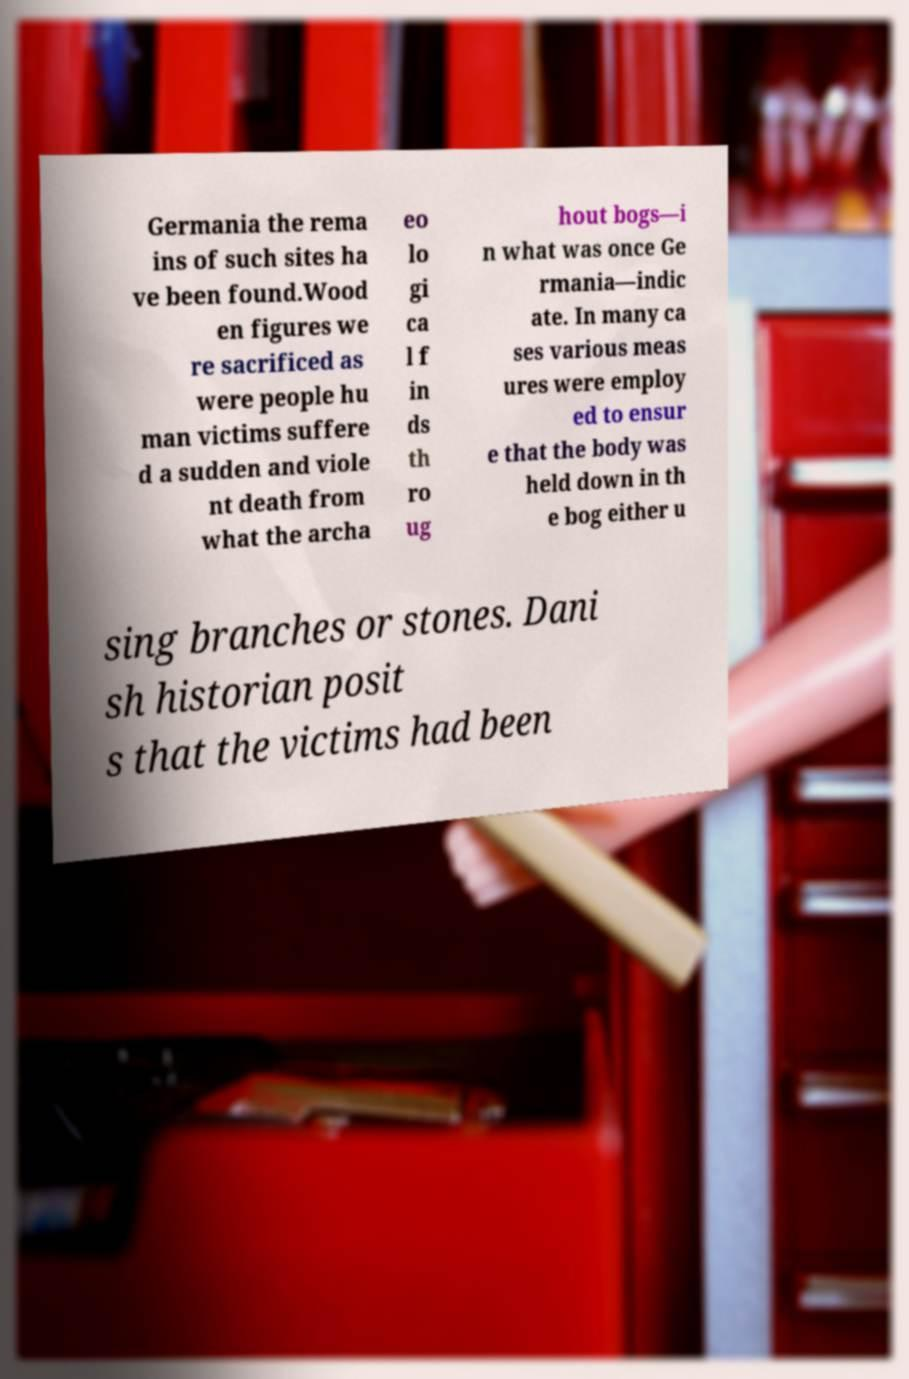I need the written content from this picture converted into text. Can you do that? Germania the rema ins of such sites ha ve been found.Wood en figures we re sacrificed as were people hu man victims suffere d a sudden and viole nt death from what the archa eo lo gi ca l f in ds th ro ug hout bogs—i n what was once Ge rmania—indic ate. In many ca ses various meas ures were employ ed to ensur e that the body was held down in th e bog either u sing branches or stones. Dani sh historian posit s that the victims had been 